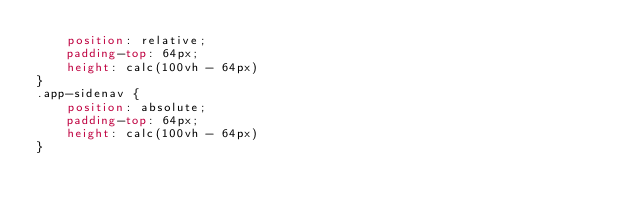Convert code to text. <code><loc_0><loc_0><loc_500><loc_500><_CSS_>    position: relative;
    padding-top: 64px; 
    height: calc(100vh - 64px)
}
.app-sidenav {
    position: absolute;
    padding-top: 64px;  
    height: calc(100vh - 64px) 
}</code> 